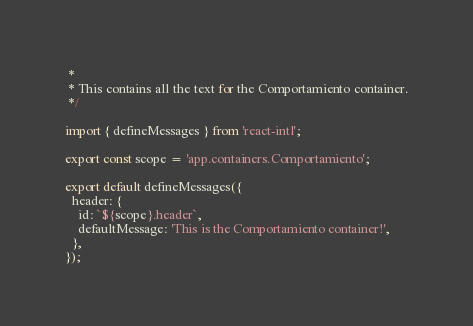Convert code to text. <code><loc_0><loc_0><loc_500><loc_500><_JavaScript_> *
 * This contains all the text for the Comportamiento container.
 */

import { defineMessages } from 'react-intl';

export const scope = 'app.containers.Comportamiento';

export default defineMessages({
  header: {
    id: `${scope}.header`,
    defaultMessage: 'This is the Comportamiento container!',
  },
});
</code> 